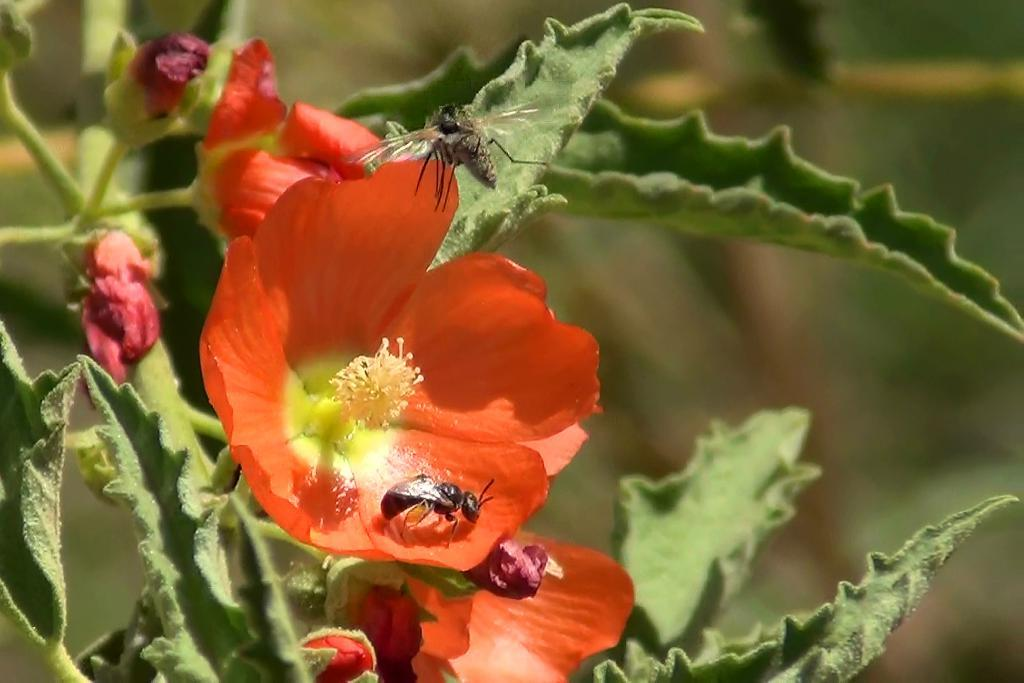What is the main subject of the image? The main subject of the image is an insect on a flower. Can you describe the plant in the image? The image contains a plant with flower buds, flowers, and leaves. Are there any other insects visible in the image? Yes, there is another insect flying in the image. How would you describe the background of the image? The background of the image appears blurry. What type of trousers is the insect wearing while teaching in the image? There are no trousers or teaching activities present in the image; it features insects on a plant. 